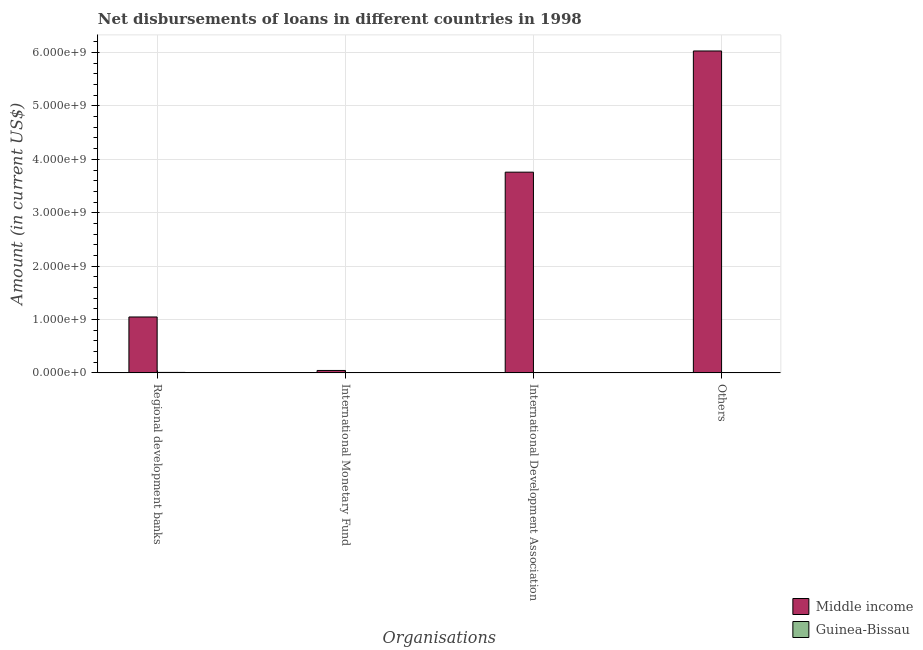How many different coloured bars are there?
Offer a terse response. 2. Are the number of bars on each tick of the X-axis equal?
Ensure brevity in your answer.  No. What is the label of the 1st group of bars from the left?
Keep it short and to the point. Regional development banks. What is the amount of loan disimbursed by international monetary fund in Guinea-Bissau?
Keep it short and to the point. 2.60e+06. Across all countries, what is the maximum amount of loan disimbursed by regional development banks?
Your response must be concise. 1.05e+09. Across all countries, what is the minimum amount of loan disimbursed by international monetary fund?
Give a very brief answer. 2.60e+06. In which country was the amount of loan disimbursed by international development association maximum?
Provide a short and direct response. Middle income. What is the total amount of loan disimbursed by regional development banks in the graph?
Provide a short and direct response. 1.06e+09. What is the difference between the amount of loan disimbursed by international monetary fund in Guinea-Bissau and that in Middle income?
Offer a very short reply. -4.26e+07. What is the difference between the amount of loan disimbursed by international development association in Guinea-Bissau and the amount of loan disimbursed by international monetary fund in Middle income?
Your response must be concise. -4.04e+07. What is the average amount of loan disimbursed by other organisations per country?
Give a very brief answer. 3.02e+09. What is the difference between the amount of loan disimbursed by international development association and amount of loan disimbursed by regional development banks in Middle income?
Keep it short and to the point. 2.71e+09. In how many countries, is the amount of loan disimbursed by other organisations greater than 1400000000 US$?
Keep it short and to the point. 1. What is the ratio of the amount of loan disimbursed by regional development banks in Guinea-Bissau to that in Middle income?
Your answer should be compact. 0.01. Is the amount of loan disimbursed by regional development banks in Middle income less than that in Guinea-Bissau?
Ensure brevity in your answer.  No. Is the difference between the amount of loan disimbursed by international development association in Middle income and Guinea-Bissau greater than the difference between the amount of loan disimbursed by regional development banks in Middle income and Guinea-Bissau?
Your answer should be very brief. Yes. What is the difference between the highest and the second highest amount of loan disimbursed by regional development banks?
Make the answer very short. 1.04e+09. What is the difference between the highest and the lowest amount of loan disimbursed by other organisations?
Your answer should be very brief. 6.03e+09. In how many countries, is the amount of loan disimbursed by international development association greater than the average amount of loan disimbursed by international development association taken over all countries?
Ensure brevity in your answer.  1. Is the sum of the amount of loan disimbursed by international development association in Guinea-Bissau and Middle income greater than the maximum amount of loan disimbursed by other organisations across all countries?
Provide a short and direct response. No. Is it the case that in every country, the sum of the amount of loan disimbursed by regional development banks and amount of loan disimbursed by international monetary fund is greater than the amount of loan disimbursed by international development association?
Offer a very short reply. No. How many bars are there?
Give a very brief answer. 7. What is the difference between two consecutive major ticks on the Y-axis?
Provide a succinct answer. 1.00e+09. Are the values on the major ticks of Y-axis written in scientific E-notation?
Make the answer very short. Yes. Does the graph contain grids?
Your answer should be very brief. Yes. Where does the legend appear in the graph?
Your response must be concise. Bottom right. What is the title of the graph?
Make the answer very short. Net disbursements of loans in different countries in 1998. What is the label or title of the X-axis?
Your answer should be very brief. Organisations. What is the label or title of the Y-axis?
Provide a succinct answer. Amount (in current US$). What is the Amount (in current US$) of Middle income in Regional development banks?
Provide a short and direct response. 1.05e+09. What is the Amount (in current US$) of Guinea-Bissau in Regional development banks?
Make the answer very short. 8.37e+06. What is the Amount (in current US$) of Middle income in International Monetary Fund?
Make the answer very short. 4.51e+07. What is the Amount (in current US$) in Guinea-Bissau in International Monetary Fund?
Your answer should be compact. 2.60e+06. What is the Amount (in current US$) of Middle income in International Development Association?
Ensure brevity in your answer.  3.76e+09. What is the Amount (in current US$) of Guinea-Bissau in International Development Association?
Your response must be concise. 4.79e+06. What is the Amount (in current US$) in Middle income in Others?
Offer a very short reply. 6.03e+09. What is the Amount (in current US$) of Guinea-Bissau in Others?
Offer a very short reply. 0. Across all Organisations, what is the maximum Amount (in current US$) in Middle income?
Your response must be concise. 6.03e+09. Across all Organisations, what is the maximum Amount (in current US$) of Guinea-Bissau?
Provide a short and direct response. 8.37e+06. Across all Organisations, what is the minimum Amount (in current US$) in Middle income?
Offer a very short reply. 4.51e+07. Across all Organisations, what is the minimum Amount (in current US$) in Guinea-Bissau?
Provide a succinct answer. 0. What is the total Amount (in current US$) in Middle income in the graph?
Your answer should be very brief. 1.09e+1. What is the total Amount (in current US$) of Guinea-Bissau in the graph?
Your response must be concise. 1.58e+07. What is the difference between the Amount (in current US$) of Middle income in Regional development banks and that in International Monetary Fund?
Offer a very short reply. 1.00e+09. What is the difference between the Amount (in current US$) in Guinea-Bissau in Regional development banks and that in International Monetary Fund?
Ensure brevity in your answer.  5.78e+06. What is the difference between the Amount (in current US$) of Middle income in Regional development banks and that in International Development Association?
Your answer should be compact. -2.71e+09. What is the difference between the Amount (in current US$) of Guinea-Bissau in Regional development banks and that in International Development Association?
Provide a short and direct response. 3.58e+06. What is the difference between the Amount (in current US$) of Middle income in Regional development banks and that in Others?
Offer a very short reply. -4.98e+09. What is the difference between the Amount (in current US$) in Middle income in International Monetary Fund and that in International Development Association?
Your answer should be compact. -3.71e+09. What is the difference between the Amount (in current US$) of Guinea-Bissau in International Monetary Fund and that in International Development Association?
Ensure brevity in your answer.  -2.20e+06. What is the difference between the Amount (in current US$) of Middle income in International Monetary Fund and that in Others?
Your answer should be compact. -5.99e+09. What is the difference between the Amount (in current US$) in Middle income in International Development Association and that in Others?
Your answer should be very brief. -2.27e+09. What is the difference between the Amount (in current US$) in Middle income in Regional development banks and the Amount (in current US$) in Guinea-Bissau in International Monetary Fund?
Provide a short and direct response. 1.04e+09. What is the difference between the Amount (in current US$) in Middle income in Regional development banks and the Amount (in current US$) in Guinea-Bissau in International Development Association?
Ensure brevity in your answer.  1.04e+09. What is the difference between the Amount (in current US$) of Middle income in International Monetary Fund and the Amount (in current US$) of Guinea-Bissau in International Development Association?
Give a very brief answer. 4.04e+07. What is the average Amount (in current US$) in Middle income per Organisations?
Offer a terse response. 2.72e+09. What is the average Amount (in current US$) of Guinea-Bissau per Organisations?
Your answer should be compact. 3.94e+06. What is the difference between the Amount (in current US$) in Middle income and Amount (in current US$) in Guinea-Bissau in Regional development banks?
Offer a very short reply. 1.04e+09. What is the difference between the Amount (in current US$) of Middle income and Amount (in current US$) of Guinea-Bissau in International Monetary Fund?
Offer a very short reply. 4.26e+07. What is the difference between the Amount (in current US$) in Middle income and Amount (in current US$) in Guinea-Bissau in International Development Association?
Offer a terse response. 3.75e+09. What is the ratio of the Amount (in current US$) of Middle income in Regional development banks to that in International Monetary Fund?
Ensure brevity in your answer.  23.19. What is the ratio of the Amount (in current US$) of Guinea-Bissau in Regional development banks to that in International Monetary Fund?
Your answer should be compact. 3.23. What is the ratio of the Amount (in current US$) in Middle income in Regional development banks to that in International Development Association?
Offer a terse response. 0.28. What is the ratio of the Amount (in current US$) of Guinea-Bissau in Regional development banks to that in International Development Association?
Provide a short and direct response. 1.75. What is the ratio of the Amount (in current US$) in Middle income in Regional development banks to that in Others?
Provide a short and direct response. 0.17. What is the ratio of the Amount (in current US$) in Middle income in International Monetary Fund to that in International Development Association?
Your response must be concise. 0.01. What is the ratio of the Amount (in current US$) in Guinea-Bissau in International Monetary Fund to that in International Development Association?
Make the answer very short. 0.54. What is the ratio of the Amount (in current US$) of Middle income in International Monetary Fund to that in Others?
Keep it short and to the point. 0.01. What is the ratio of the Amount (in current US$) in Middle income in International Development Association to that in Others?
Offer a terse response. 0.62. What is the difference between the highest and the second highest Amount (in current US$) in Middle income?
Make the answer very short. 2.27e+09. What is the difference between the highest and the second highest Amount (in current US$) of Guinea-Bissau?
Your response must be concise. 3.58e+06. What is the difference between the highest and the lowest Amount (in current US$) of Middle income?
Your answer should be very brief. 5.99e+09. What is the difference between the highest and the lowest Amount (in current US$) in Guinea-Bissau?
Provide a succinct answer. 8.37e+06. 